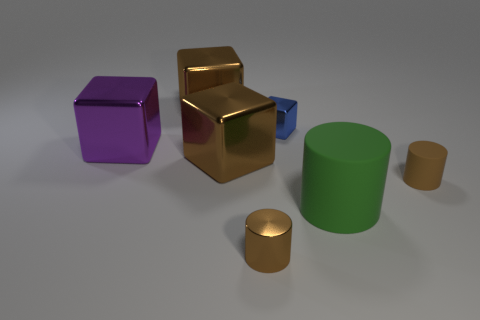Subtract all green blocks. Subtract all blue cylinders. How many blocks are left? 4 Add 2 big metallic blocks. How many objects exist? 9 Subtract all cubes. How many objects are left? 3 Add 7 purple cubes. How many purple cubes exist? 8 Subtract 0 cyan spheres. How many objects are left? 7 Subtract all brown shiny objects. Subtract all large green cylinders. How many objects are left? 3 Add 3 tiny blue metal cubes. How many tiny blue metal cubes are left? 4 